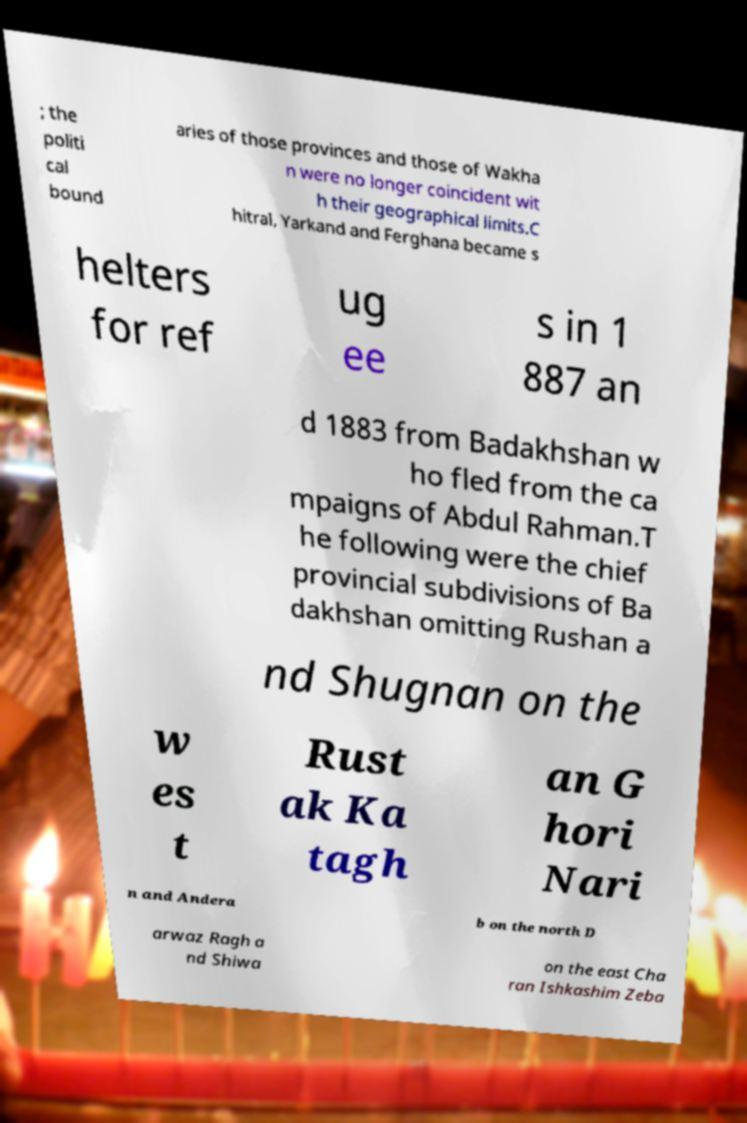Please identify and transcribe the text found in this image. ; the politi cal bound aries of those provinces and those of Wakha n were no longer coincident wit h their geographical limits.C hitral, Yarkand and Ferghana became s helters for ref ug ee s in 1 887 an d 1883 from Badakhshan w ho fled from the ca mpaigns of Abdul Rahman.T he following were the chief provincial subdivisions of Ba dakhshan omitting Rushan a nd Shugnan on the w es t Rust ak Ka tagh an G hori Nari n and Andera b on the north D arwaz Ragh a nd Shiwa on the east Cha ran Ishkashim Zeba 